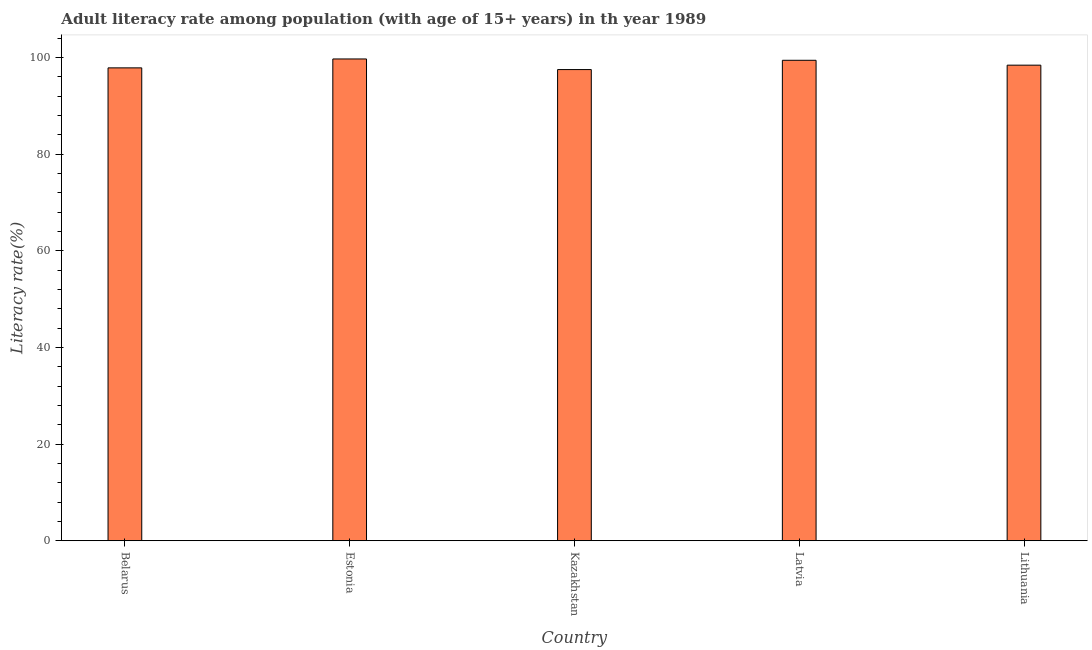What is the title of the graph?
Provide a succinct answer. Adult literacy rate among population (with age of 15+ years) in th year 1989. What is the label or title of the X-axis?
Offer a very short reply. Country. What is the label or title of the Y-axis?
Your response must be concise. Literacy rate(%). What is the adult literacy rate in Kazakhstan?
Keep it short and to the point. 97.53. Across all countries, what is the maximum adult literacy rate?
Keep it short and to the point. 99.73. Across all countries, what is the minimum adult literacy rate?
Ensure brevity in your answer.  97.53. In which country was the adult literacy rate maximum?
Provide a short and direct response. Estonia. In which country was the adult literacy rate minimum?
Make the answer very short. Kazakhstan. What is the sum of the adult literacy rate?
Provide a succinct answer. 493.03. What is the difference between the adult literacy rate in Kazakhstan and Latvia?
Ensure brevity in your answer.  -1.92. What is the average adult literacy rate per country?
Your response must be concise. 98.61. What is the median adult literacy rate?
Your answer should be compact. 98.44. In how many countries, is the adult literacy rate greater than 48 %?
Your response must be concise. 5. What is the ratio of the adult literacy rate in Kazakhstan to that in Lithuania?
Give a very brief answer. 0.99. What is the difference between the highest and the second highest adult literacy rate?
Offer a very short reply. 0.27. Is the sum of the adult literacy rate in Belarus and Kazakhstan greater than the maximum adult literacy rate across all countries?
Ensure brevity in your answer.  Yes. What is the difference between the highest and the lowest adult literacy rate?
Your answer should be very brief. 2.2. How many bars are there?
Provide a succinct answer. 5. Are all the bars in the graph horizontal?
Your answer should be compact. No. Are the values on the major ticks of Y-axis written in scientific E-notation?
Offer a terse response. No. What is the Literacy rate(%) in Belarus?
Make the answer very short. 97.88. What is the Literacy rate(%) in Estonia?
Ensure brevity in your answer.  99.73. What is the Literacy rate(%) in Kazakhstan?
Offer a very short reply. 97.53. What is the Literacy rate(%) in Latvia?
Offer a terse response. 99.45. What is the Literacy rate(%) of Lithuania?
Provide a succinct answer. 98.44. What is the difference between the Literacy rate(%) in Belarus and Estonia?
Your answer should be very brief. -1.84. What is the difference between the Literacy rate(%) in Belarus and Kazakhstan?
Your response must be concise. 0.35. What is the difference between the Literacy rate(%) in Belarus and Latvia?
Give a very brief answer. -1.57. What is the difference between the Literacy rate(%) in Belarus and Lithuania?
Provide a short and direct response. -0.56. What is the difference between the Literacy rate(%) in Estonia and Kazakhstan?
Ensure brevity in your answer.  2.2. What is the difference between the Literacy rate(%) in Estonia and Latvia?
Offer a very short reply. 0.27. What is the difference between the Literacy rate(%) in Estonia and Lithuania?
Provide a succinct answer. 1.29. What is the difference between the Literacy rate(%) in Kazakhstan and Latvia?
Your response must be concise. -1.92. What is the difference between the Literacy rate(%) in Kazakhstan and Lithuania?
Your answer should be very brief. -0.91. What is the difference between the Literacy rate(%) in Latvia and Lithuania?
Provide a succinct answer. 1.01. What is the ratio of the Literacy rate(%) in Belarus to that in Kazakhstan?
Offer a very short reply. 1. What is the ratio of the Literacy rate(%) in Belarus to that in Latvia?
Offer a very short reply. 0.98. What is the ratio of the Literacy rate(%) in Estonia to that in Lithuania?
Make the answer very short. 1.01. 